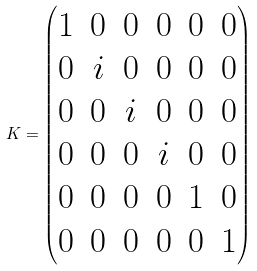<formula> <loc_0><loc_0><loc_500><loc_500>K = \begin{pmatrix} 1 & 0 & 0 & 0 & 0 & 0 \\ 0 & i & 0 & 0 & 0 & 0 \\ 0 & 0 & i & 0 & 0 & 0 \\ 0 & 0 & 0 & i & 0 & 0 \\ 0 & 0 & 0 & 0 & 1 & 0 \\ 0 & 0 & 0 & 0 & 0 & 1 \end{pmatrix}</formula> 